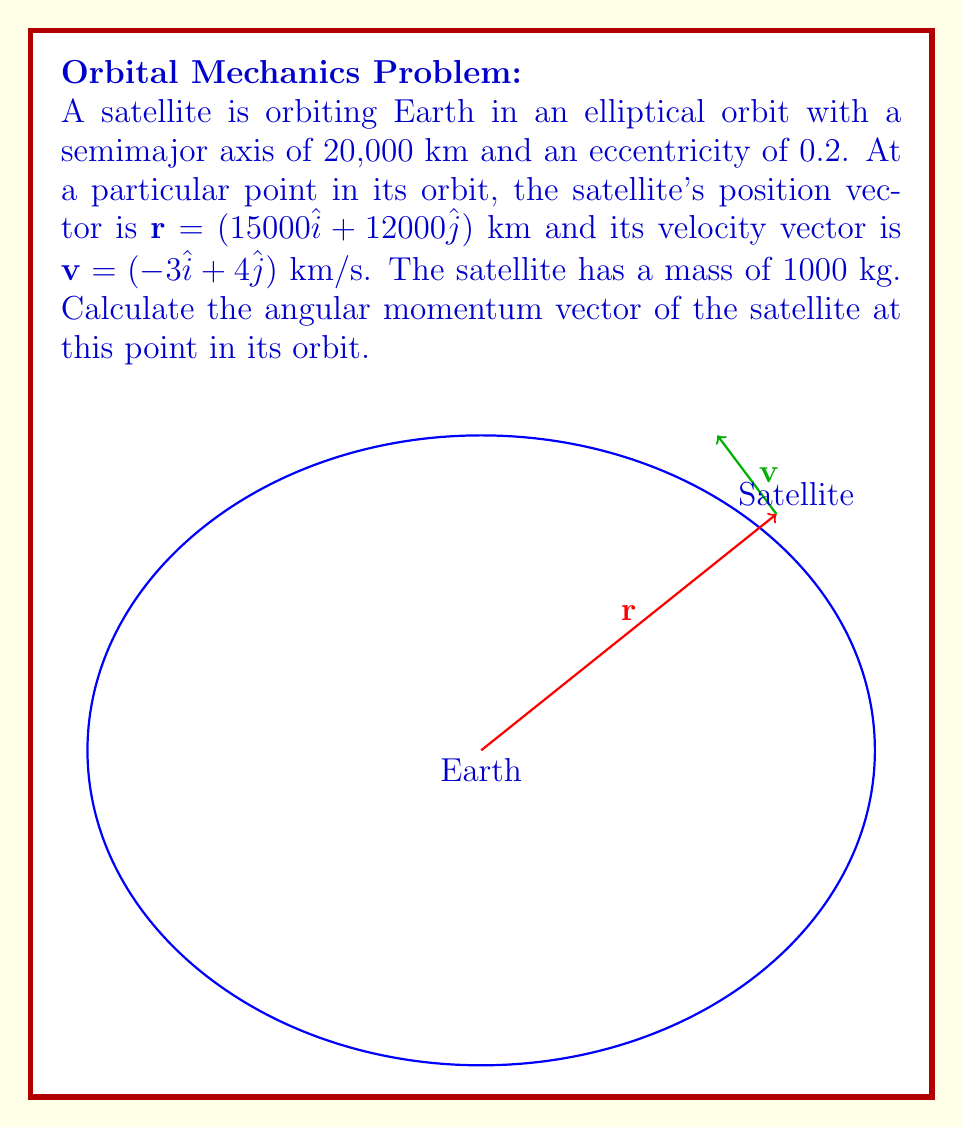Solve this math problem. To calculate the angular momentum vector, we'll follow these steps:

1) The angular momentum vector $\mathbf{h}$ is defined as:

   $$\mathbf{h} = m(\mathbf{r} \times \mathbf{v})$$

   where $m$ is the mass of the satellite, $\mathbf{r}$ is the position vector, and $\mathbf{v}$ is the velocity vector.

2) We're given:
   $m = 1000$ kg
   $\mathbf{r} = (15000\hat{i} + 12000\hat{j})$ km
   $\mathbf{v} = (-3\hat{i} + 4\hat{j})$ km/s

3) First, let's calculate the cross product $\mathbf{r} \times \mathbf{v}$:

   $$\mathbf{r} \times \mathbf{v} = \begin{vmatrix} 
   \hat{i} & \hat{j} & \hat{k} \\
   15000 & 12000 & 0 \\
   -3 & 4 & 0
   \end{vmatrix}$$

   $$= (15000 \cdot 4 - 12000 \cdot (-3))\hat{k}$$
   $$= (60000 + 36000)\hat{k} = 96000\hat{k}$$ km²/s

4) Now, we multiply by the mass:

   $$\mathbf{h} = 1000 \cdot 96000\hat{k} = 96,000,000\hat{k}$$ kg·km²/s

5) Convert units to the standard SI units (m²/s):
   
   $$\mathbf{h} = 96,000,000 \cdot 10^6\hat{k} = 9.6 \times 10^{13}\hat{k}$$ kg·m²/s

Therefore, the angular momentum vector is $9.6 \times 10^{13}\hat{k}$ kg·m²/s.
Answer: $\mathbf{h} = 9.6 \times 10^{13}\hat{k}$ kg·m²/s 